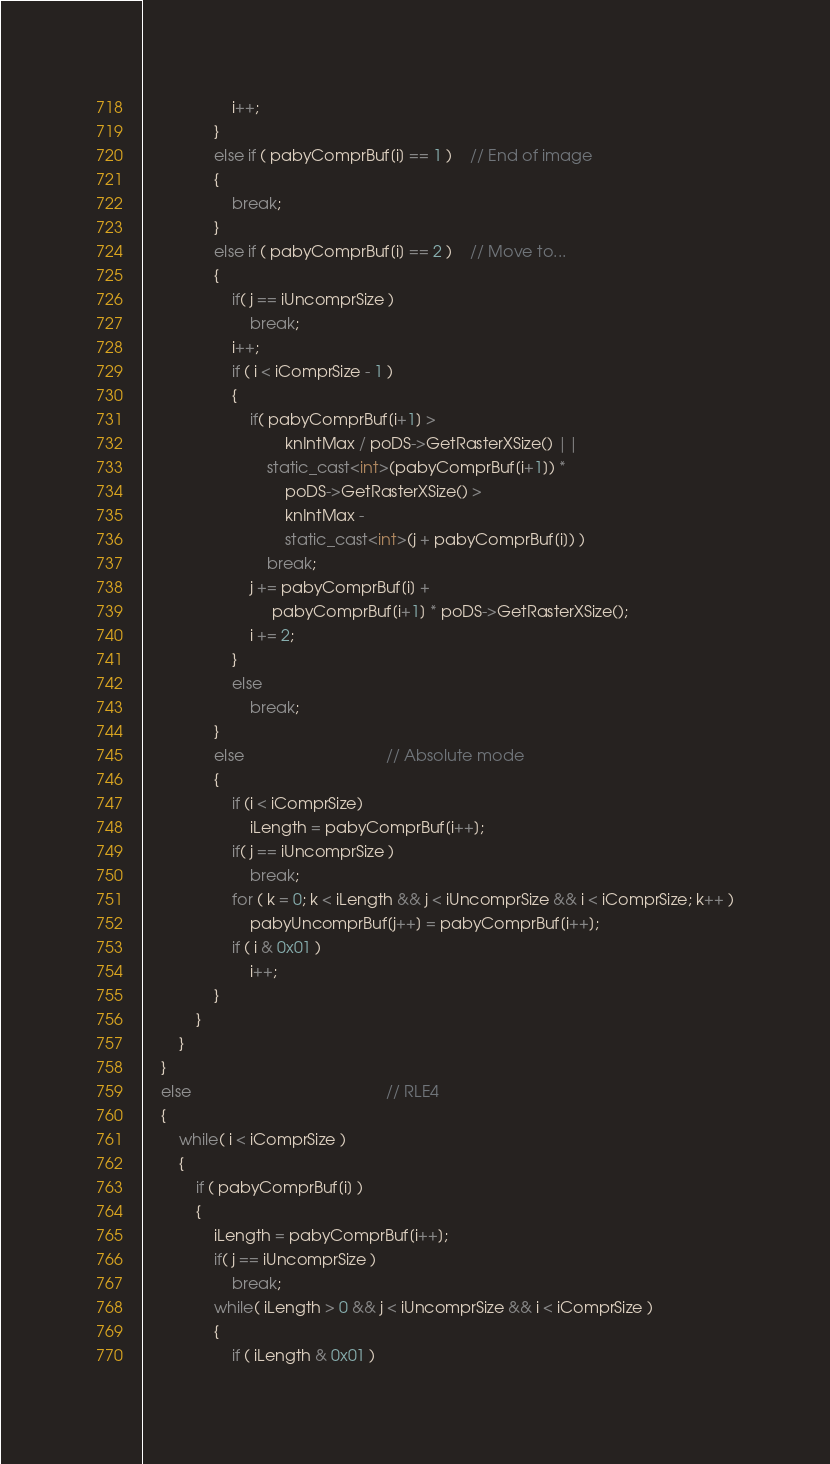Convert code to text. <code><loc_0><loc_0><loc_500><loc_500><_C++_>                    i++;
                }
                else if ( pabyComprBuf[i] == 1 )    // End of image
                {
                    break;
                }
                else if ( pabyComprBuf[i] == 2 )    // Move to...
                {
                    if( j == iUncomprSize )
                        break;
                    i++;
                    if ( i < iComprSize - 1 )
                    {
                        if( pabyComprBuf[i+1] >
                                knIntMax / poDS->GetRasterXSize() ||
                            static_cast<int>(pabyComprBuf[i+1]) *
                                poDS->GetRasterXSize() >
                                knIntMax -
                                static_cast<int>(j + pabyComprBuf[i]) )
                            break;
                        j += pabyComprBuf[i] +
                             pabyComprBuf[i+1] * poDS->GetRasterXSize();
                        i += 2;
                    }
                    else
                        break;
                }
                else                                // Absolute mode
                {
                    if (i < iComprSize)
                        iLength = pabyComprBuf[i++];
                    if( j == iUncomprSize )
                        break;
                    for ( k = 0; k < iLength && j < iUncomprSize && i < iComprSize; k++ )
                        pabyUncomprBuf[j++] = pabyComprBuf[i++];
                    if ( i & 0x01 )
                        i++;
                }
            }
        }
    }
    else                                            // RLE4
    {
        while( i < iComprSize )
        {
            if ( pabyComprBuf[i] )
            {
                iLength = pabyComprBuf[i++];
                if( j == iUncomprSize )
                    break;
                while( iLength > 0 && j < iUncomprSize && i < iComprSize )
                {
                    if ( iLength & 0x01 )</code> 